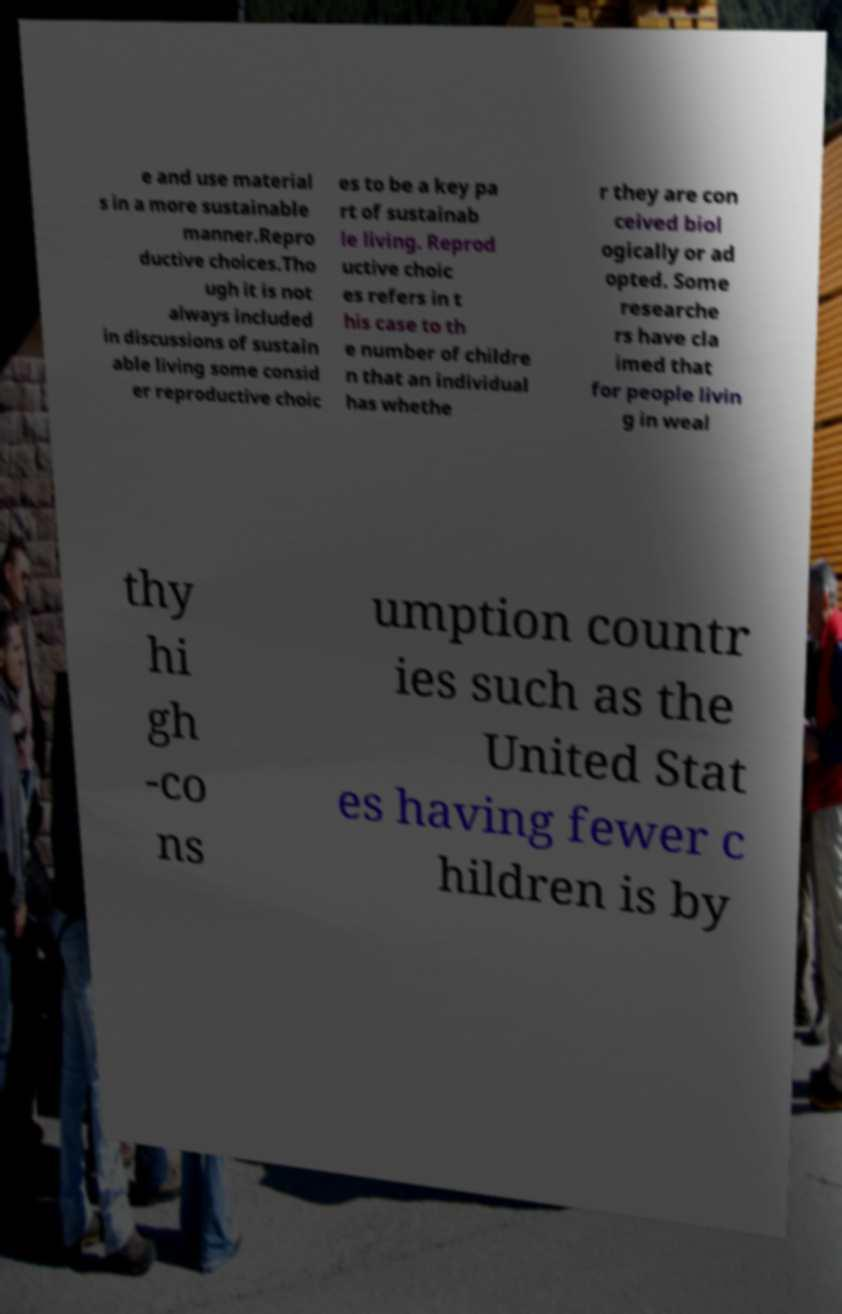There's text embedded in this image that I need extracted. Can you transcribe it verbatim? e and use material s in a more sustainable manner.Repro ductive choices.Tho ugh it is not always included in discussions of sustain able living some consid er reproductive choic es to be a key pa rt of sustainab le living. Reprod uctive choic es refers in t his case to th e number of childre n that an individual has whethe r they are con ceived biol ogically or ad opted. Some researche rs have cla imed that for people livin g in weal thy hi gh -co ns umption countr ies such as the United Stat es having fewer c hildren is by 